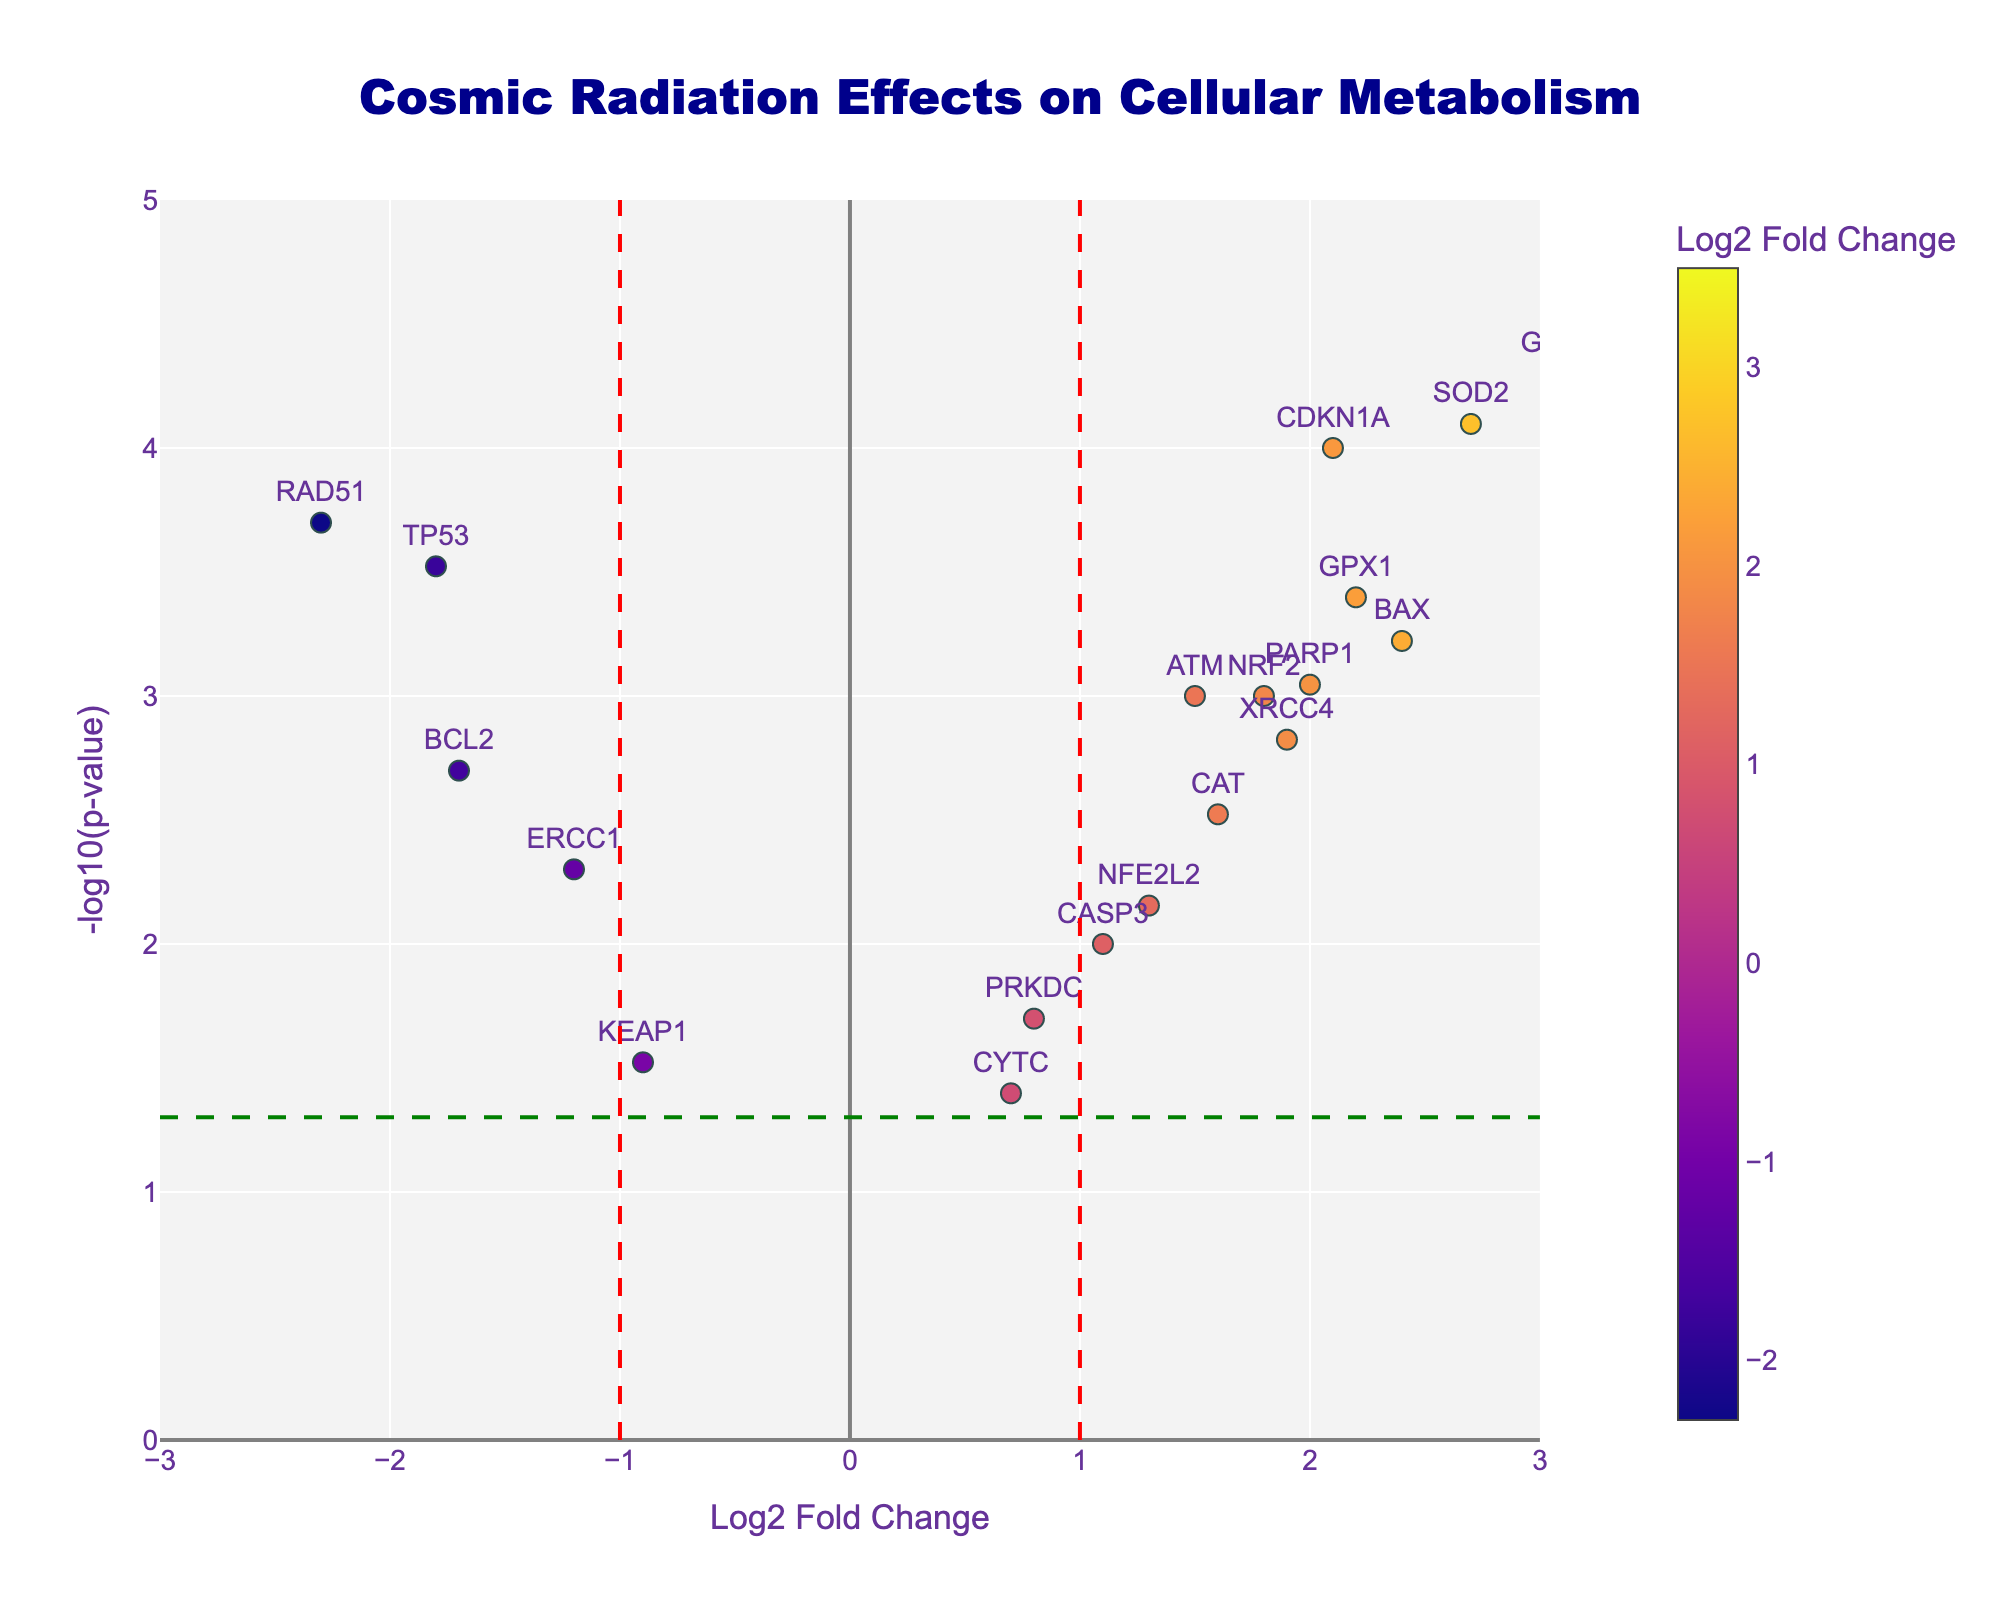What is the title of the volcano plot? The title is prominently displayed at the top of the volcano plot. It states the main focus of the plot.
Answer: Cosmic Radiation Effects on Cellular Metabolism What does the y-axis represent? The y-axis represents the negative logarithm (base 10) of the p-value, which indicates the statistical significance of the changes. The higher the value, the more significant the change.
Answer: -log10(p-value) How many genes have a Log2 Fold Change greater than 2? We need to count the number of genes with Log2 Fold Change values greater than 2 on the x-axis of the plot.
Answer: 4 (GADD45A, SOD2, HMOX1, BAX) Which gene has the highest -log10(p-value)? By looking at the y-axis and identifying the gene with the highest value. This gene will be positioned the highest on the plot.
Answer: HMOX1 Are there any genes with a log2 fold change between -1 and 1 and a p-value less than 0.05? To find this, we look within the x-axis range of -1 to 1 and check which points are above the horizontal line representing p=0.05.
Answer: Yes (CASP3, PRKDC, NFE2L2, CYTC) Which gene has the most downregulated expression due to cosmic radiation, and what is its Log2 Fold Change? To find the most downregulated gene, look for the point furthest to the left on the x-axis (most negative Log2 Fold Change).
Answer: RAD51, Log2 Fold Change: -2.3 How many genes show a statistically significant change in their expression levels? Statistically significant p-values are less than 0.05. Count the number of points above the horizontal threshold line on the plot.
Answer: 16 How does the expression of the gene TP53 compare between shielded and unshielded conditions? By interpreting TP53's position on the plot, we note its negative Log2 Fold Change, indicating downregulation under cosmic radiation.
Answer: Downregulated Which color scale is used in the volcano plot, and what does it represent? The color scale represents the Log2 Fold Change values, ranging from lower to higher changes, visualized through a gradient.
Answer: Plasma, Log2 Fold Change What threshold values are used to determine significant Log2 Fold Change? The significant thresholds on the x-axis are marked by vertical lines at Log2 Fold Change of -1 and 1.
Answer: -1 and 1 